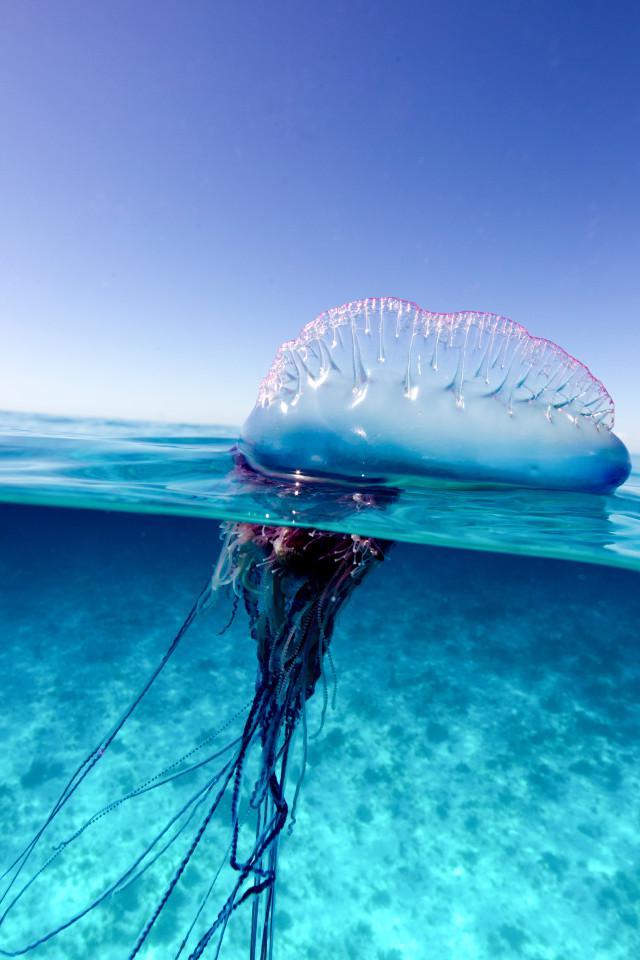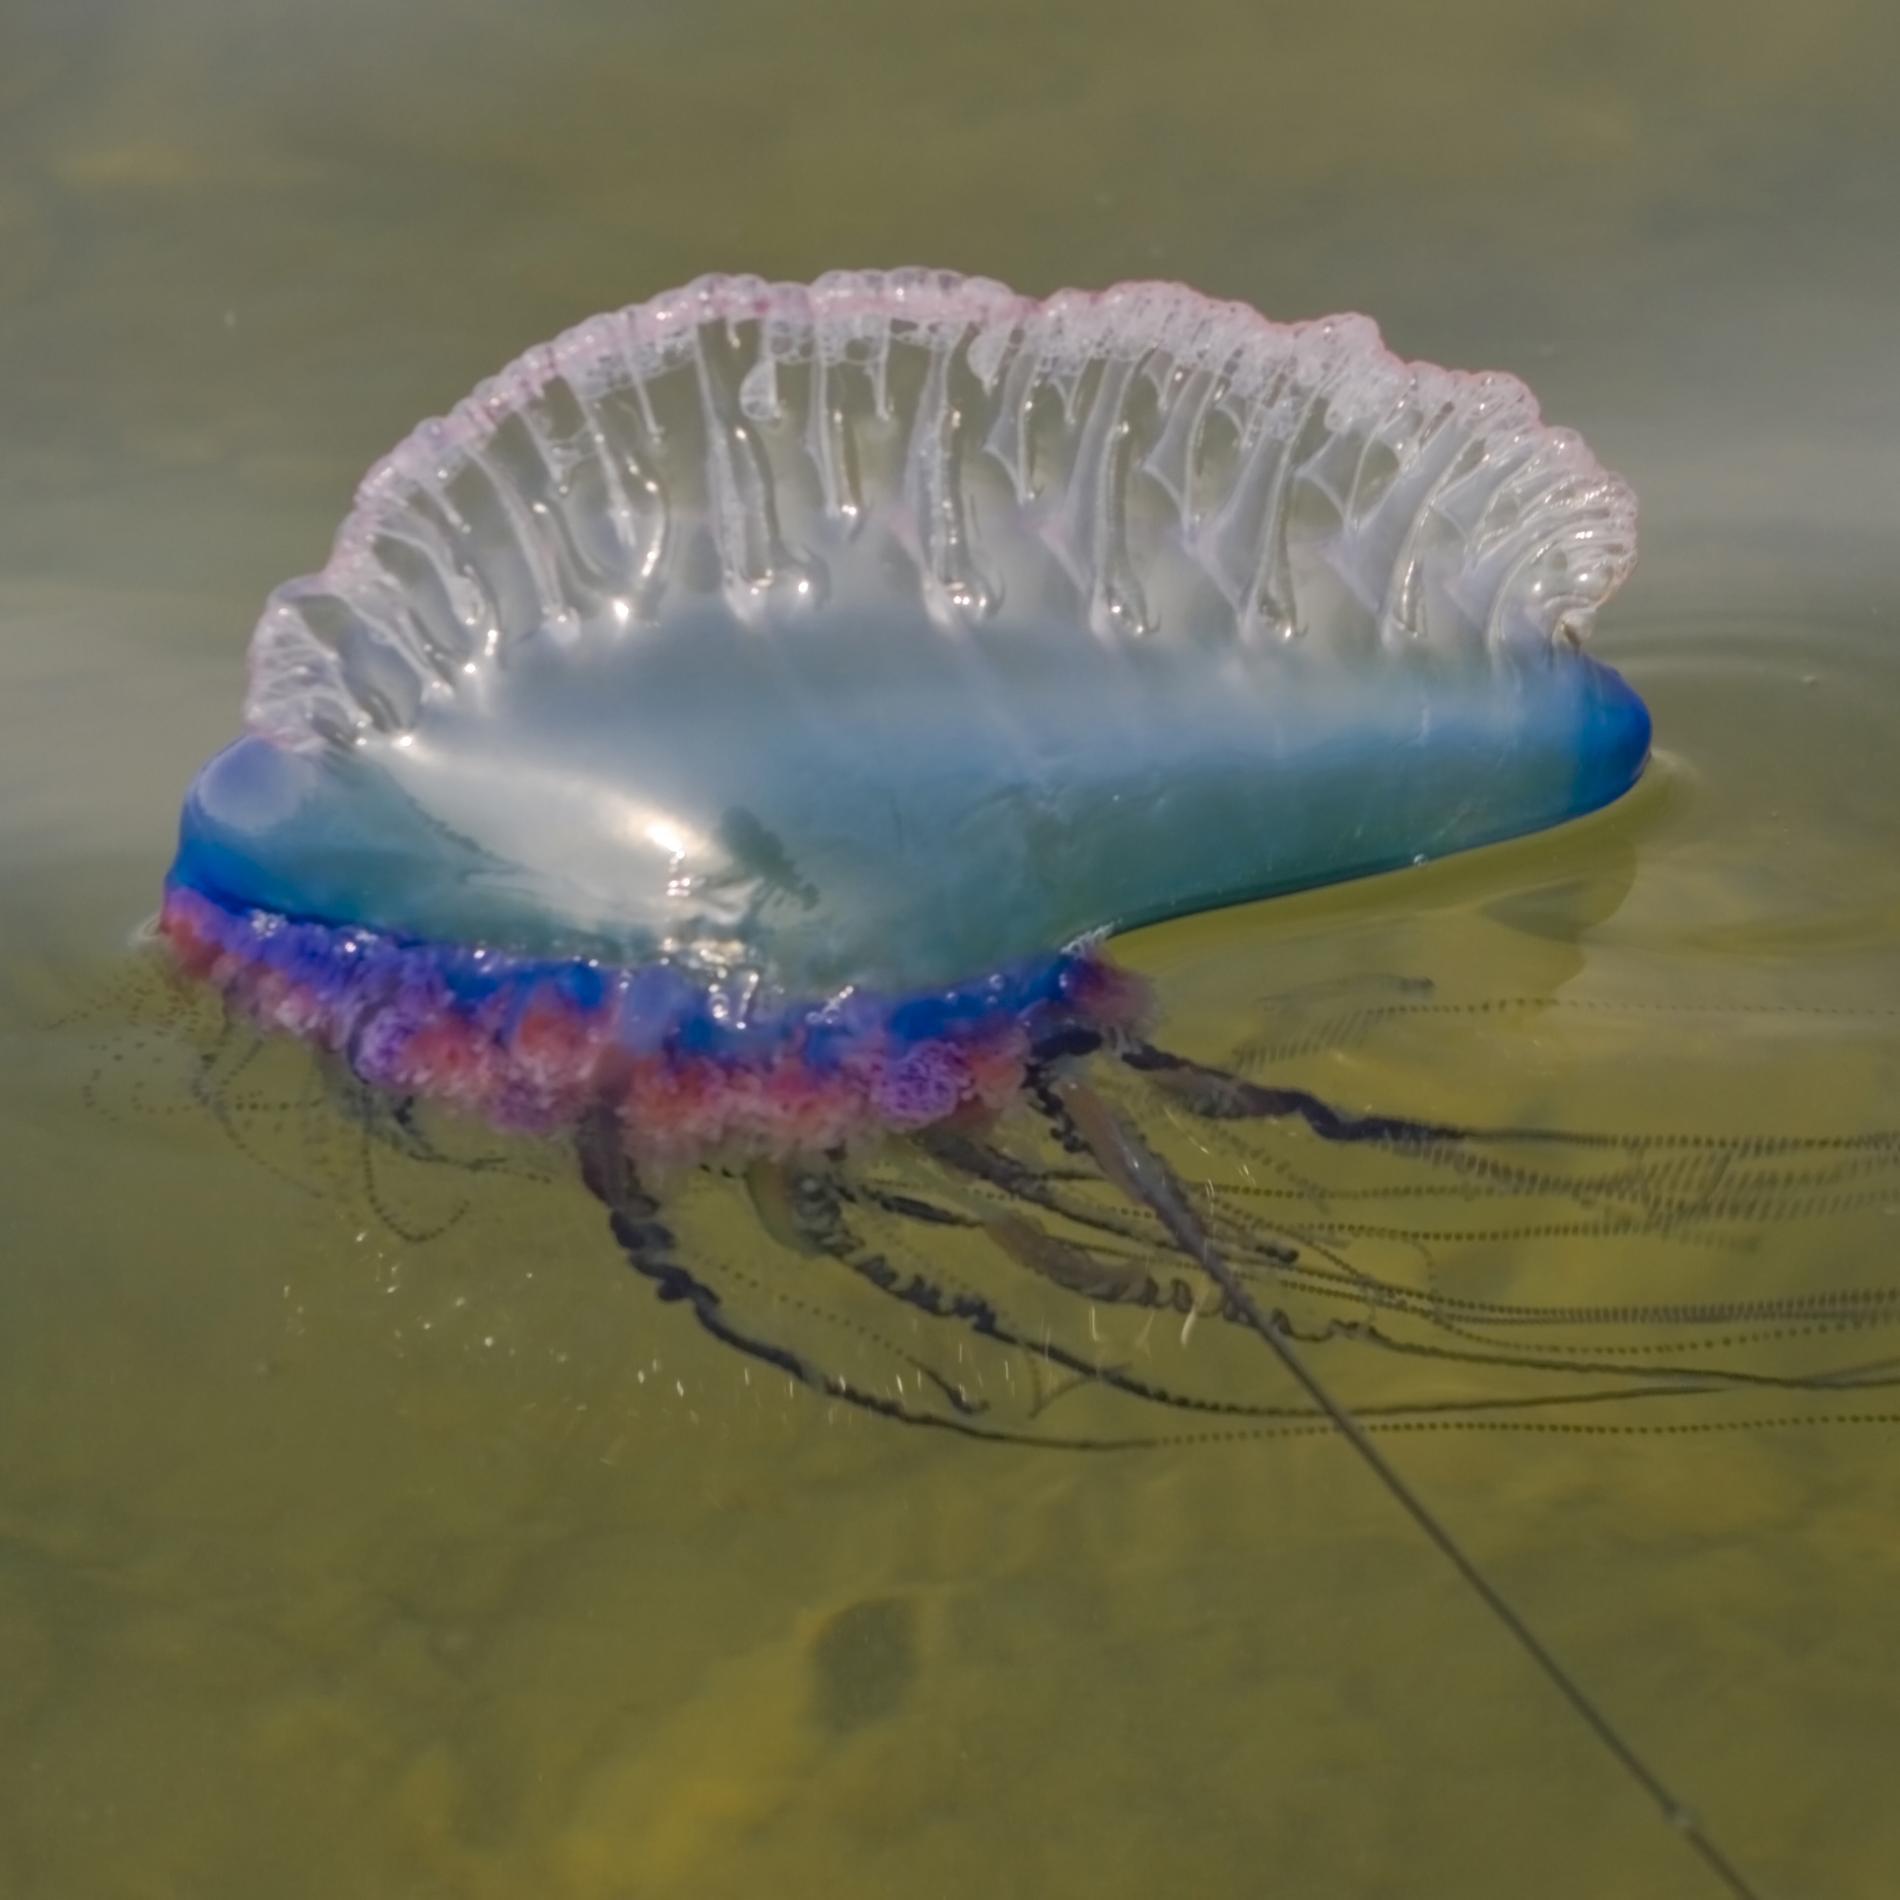The first image is the image on the left, the second image is the image on the right. Examine the images to the left and right. Is the description "All jellyfish are at least partially above the water surface." accurate? Answer yes or no. Yes. The first image is the image on the left, the second image is the image on the right. Given the left and right images, does the statement "In one image, a single jelly fish skims the top of the water with the sky in the background." hold true? Answer yes or no. Yes. 